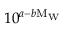Convert formula to latex. <formula><loc_0><loc_0><loc_500><loc_500>1 0 ^ { a - b M _ { W } }</formula> 